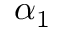<formula> <loc_0><loc_0><loc_500><loc_500>\alpha _ { 1 }</formula> 